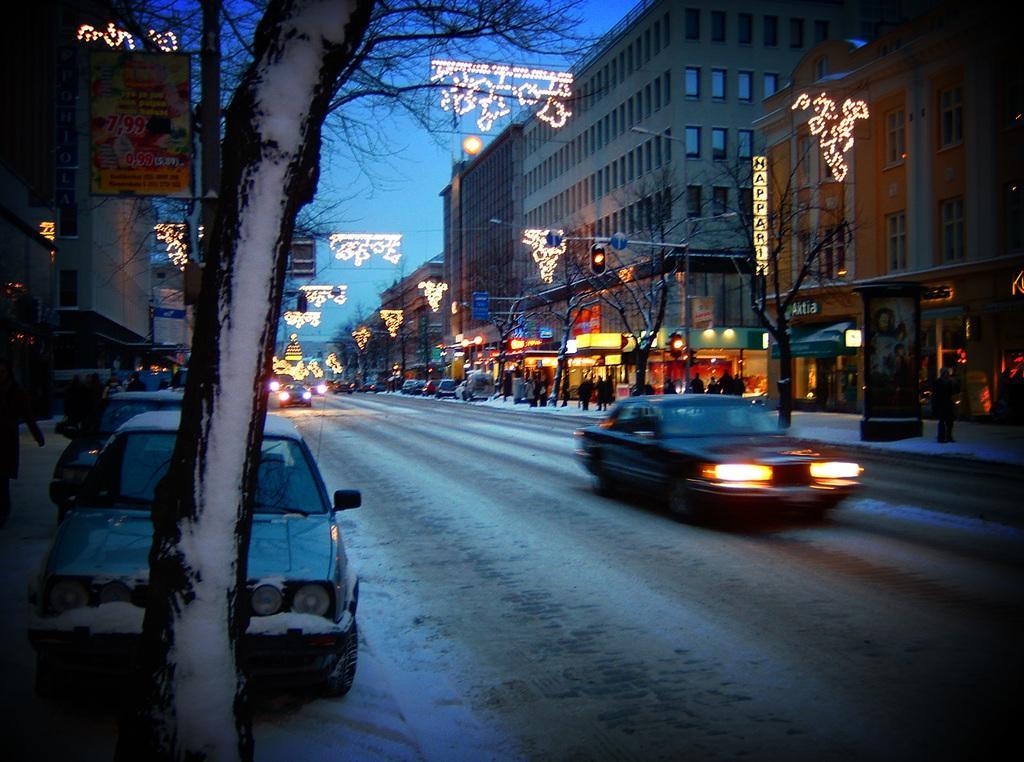Can you describe this image briefly? In the image in the center we can see few vehicles on the road. And we can see trees,traffic lights,sign boards,banners,string lights and few people were standing. In the background we can see the sky,buildings,windows etc. 